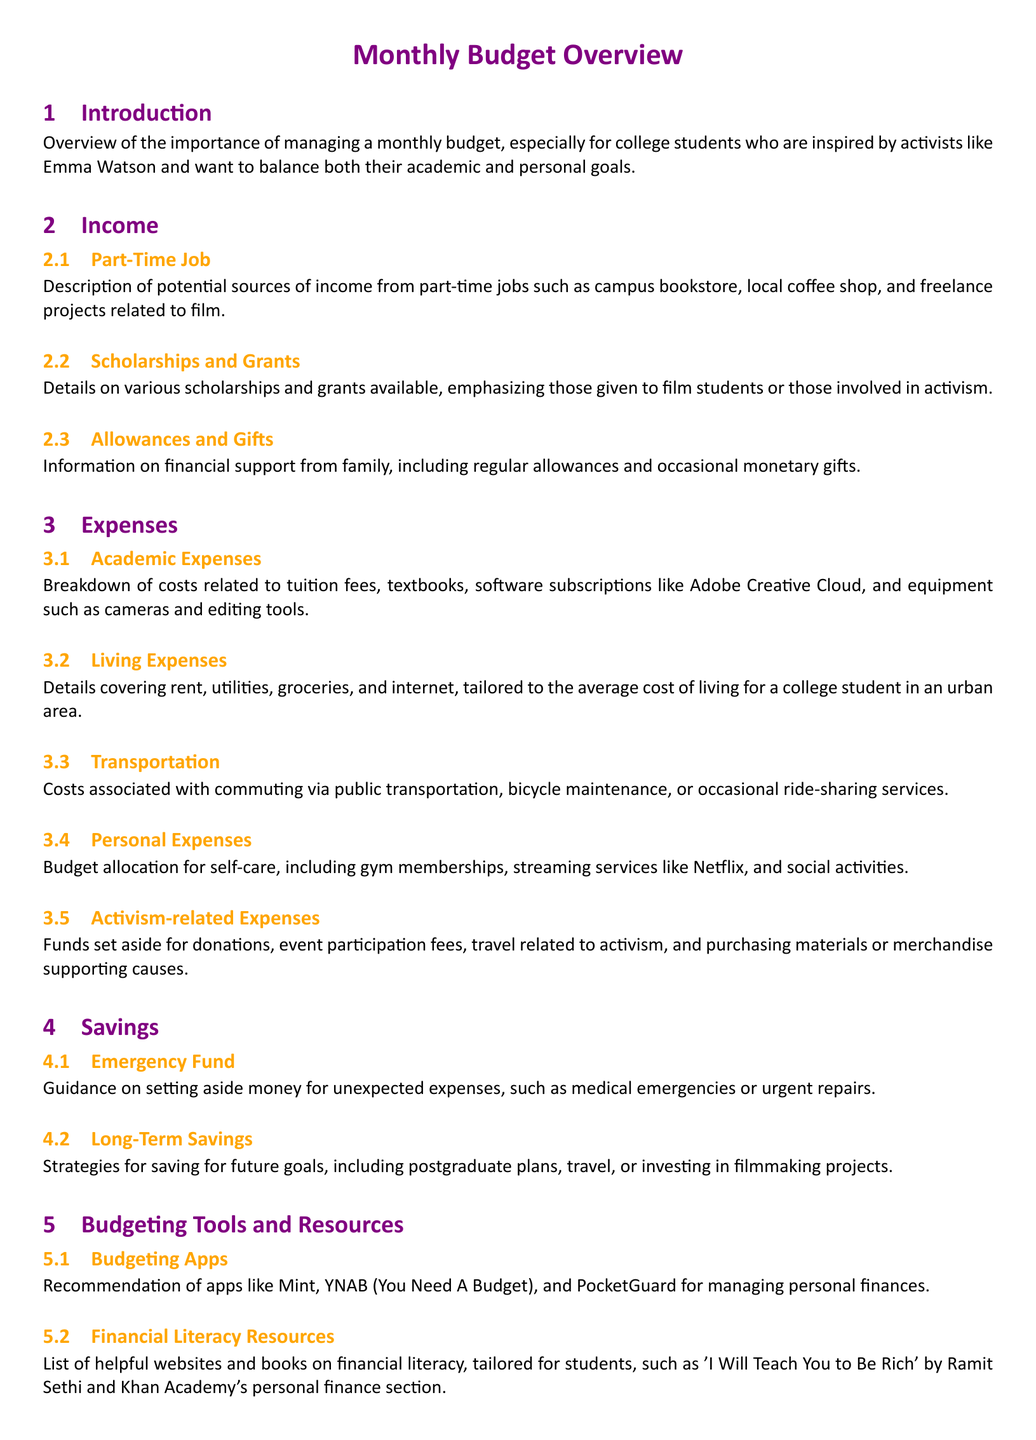what are the primary sources of income for college students? The document outlines three primary sources of income: part-time jobs, scholarships and grants, and allowances and gifts.
Answer: part-time jobs, scholarships and grants, allowances and gifts what is a suggested amount for an emergency fund? The document offers guiding principles but does not specify an exact amount for the emergency fund. The answer requires understanding that there's emphasis on setting aside money for unexpected expenses.
Answer: unspecified which app is recommended for managing personal finances? The document mentions several budgeting apps, with a notable example being Mint.
Answer: Mint what expenses are categorized under living expenses? The document specifies the types of costs associated with living, which include rent, utilities, groceries, and internet.
Answer: rent, utilities, groceries, internet how can a college student support activism financially? The document describes various activism-related expenses like donations, event participation fees, and purchasing materials or merchandise.
Answer: donations, event participation fees, materials what is one book listed in financial literacy resources? The document provides a list of resources, among which 'I Will Teach You to Be Rich' by Ramit Sethi is included.
Answer: 'I Will Teach You to Be Rich' what types of workshops are mentioned in the document? It mentions free or low-cost workshops offered on budgeting and financial management.
Answer: budgeting and financial management what are academic expenses primarily related to? The document outlines that academic expenses include costs for tuition fees, textbooks, and software subscriptions.
Answer: tuition fees, textbooks, software subscriptions what is the overall purpose of the document? The document's purpose is to provide support for college students in managing their finances effectively in relation to their academic and personal lives.
Answer: managing finances effectively 